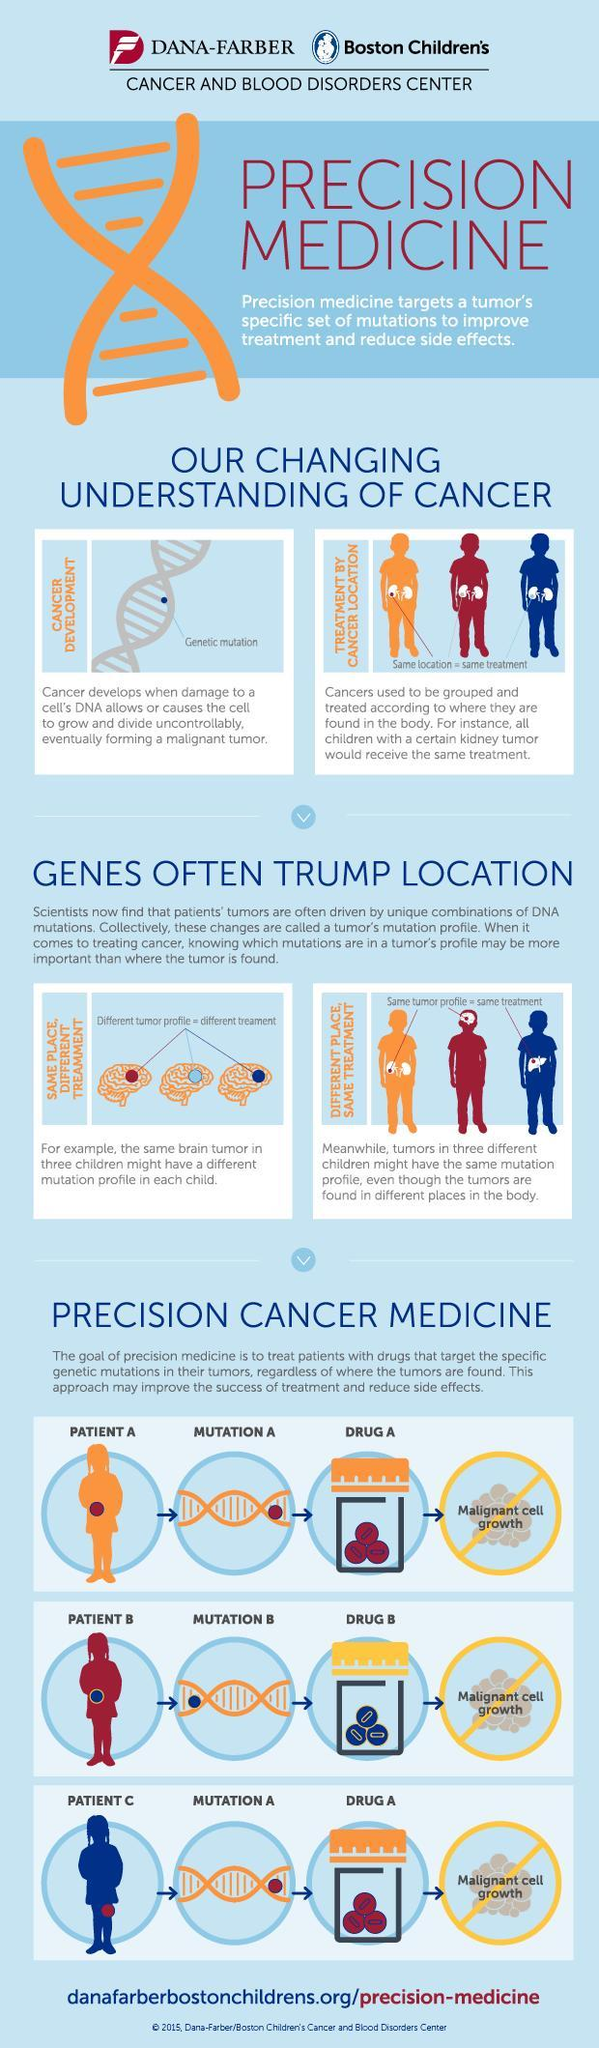which is the organ shown in the pictured related to same place, different treatment
Answer the question with a short phrase. brain which is the organ shown in the pictures related to treatment by cancer location kidney What is the colour of Drug A, red or blue red 